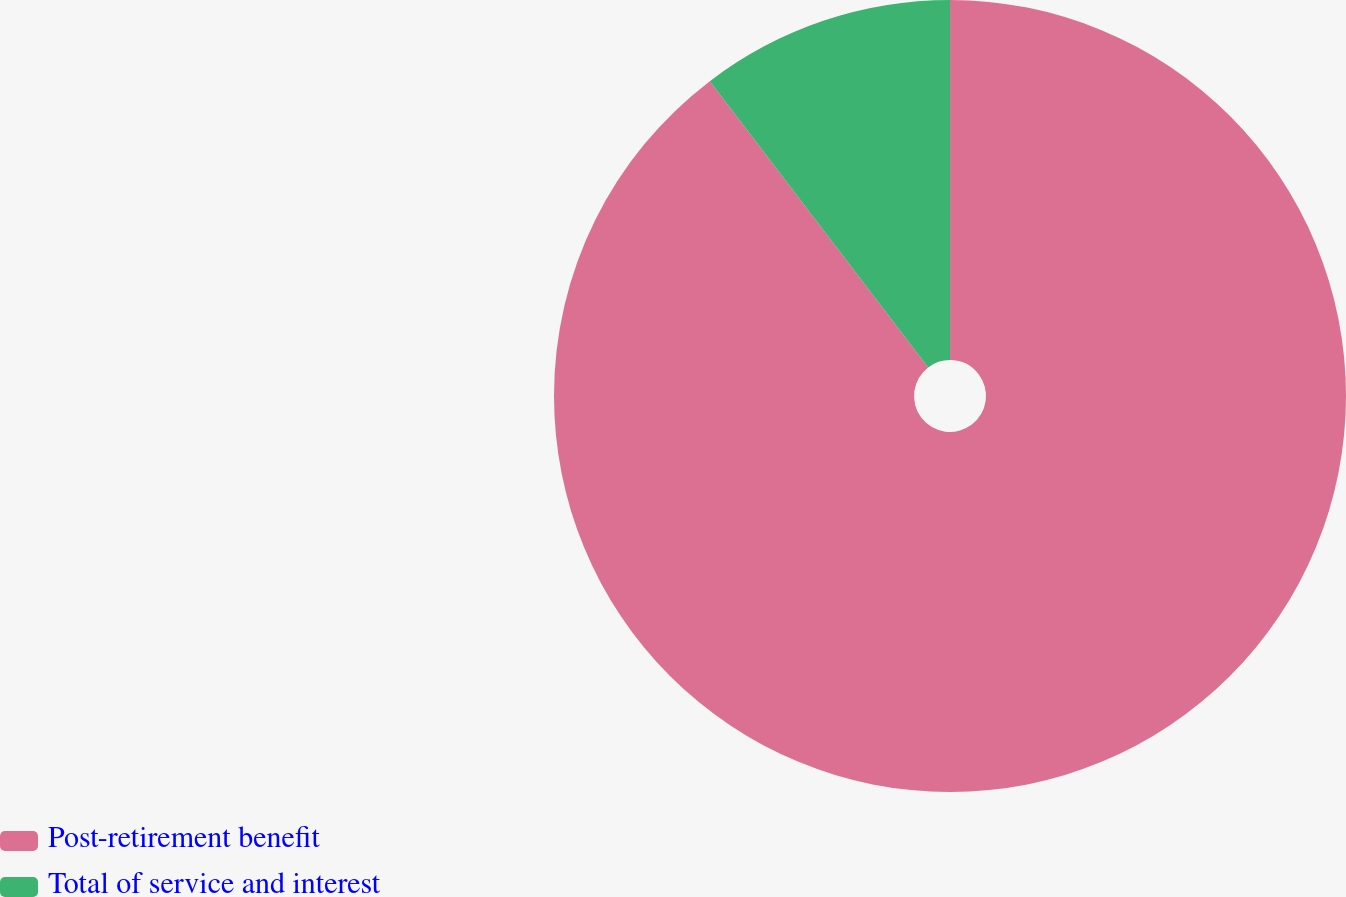Convert chart to OTSL. <chart><loc_0><loc_0><loc_500><loc_500><pie_chart><fcel>Post-retirement benefit<fcel>Total of service and interest<nl><fcel>89.63%<fcel>10.37%<nl></chart> 